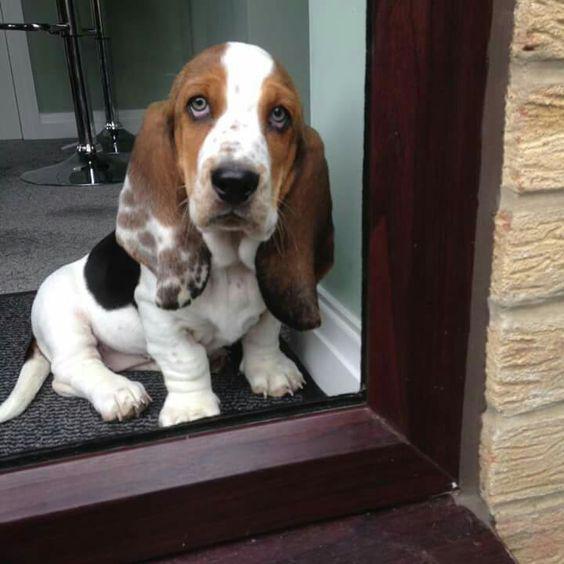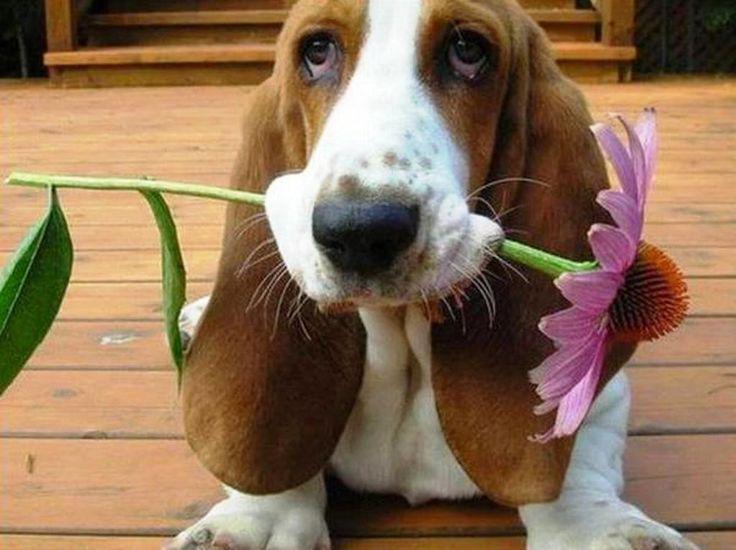The first image is the image on the left, the second image is the image on the right. For the images displayed, is the sentence "A dog is eating in both images," factually correct? Answer yes or no. No. The first image is the image on the left, the second image is the image on the right. Assess this claim about the two images: "Each image includes exactly one basset hound, which faces mostly forward, and at least one hound has an object in front of part of its face and touching part of its face.". Correct or not? Answer yes or no. Yes. 